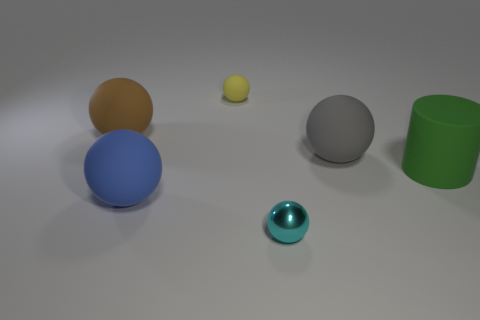What material is the large object that is in front of the gray matte ball and left of the large green cylinder?
Make the answer very short. Rubber. How many other things are made of the same material as the tiny yellow ball?
Provide a succinct answer. 4. How many other small shiny objects are the same color as the metallic object?
Your response must be concise. 0. What size is the sphere to the right of the small thing that is to the right of the sphere that is behind the brown matte thing?
Provide a short and direct response. Large. What number of shiny things are cylinders or yellow balls?
Offer a terse response. 0. Does the metallic thing have the same shape as the large matte thing to the right of the big gray thing?
Your answer should be compact. No. Is the number of small metal spheres in front of the gray sphere greater than the number of small yellow matte things that are behind the tiny matte object?
Ensure brevity in your answer.  Yes. There is a tiny object that is right of the tiny sphere behind the large green rubber thing; is there a large brown object in front of it?
Ensure brevity in your answer.  No. There is a tiny thing that is in front of the cylinder; does it have the same shape as the gray thing?
Offer a very short reply. Yes. Is the number of matte spheres on the right side of the small yellow object less than the number of big rubber balls behind the blue matte sphere?
Your response must be concise. Yes. 